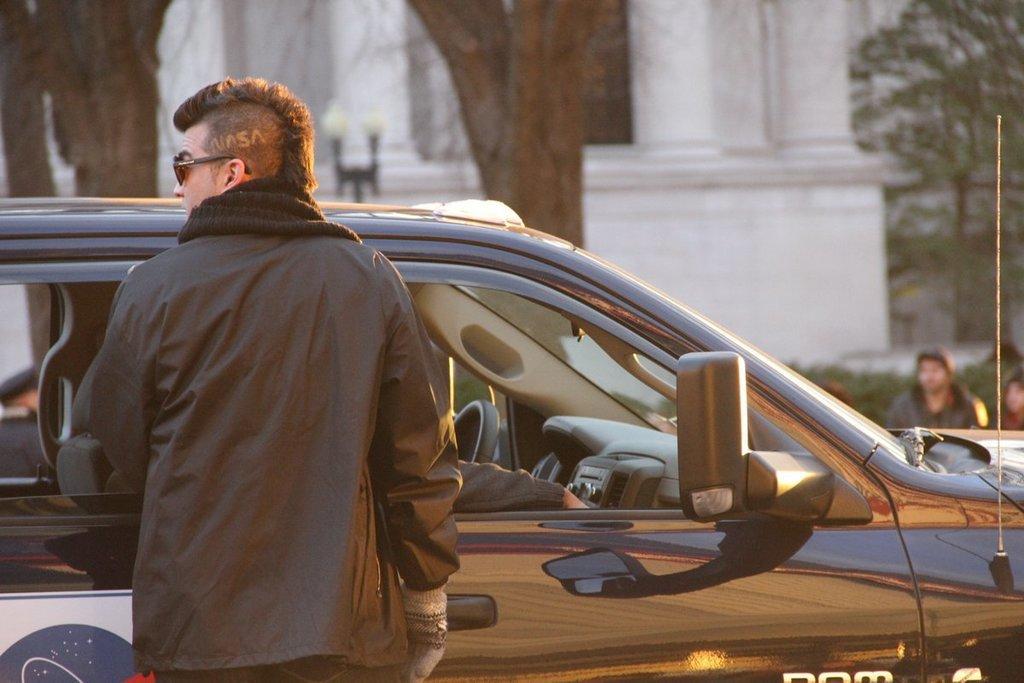In one or two sentences, can you explain what this image depicts? In this image I see a man who is near the car and I see a person's hand in the car. In the background I see a building, few trees and few persons over here. 